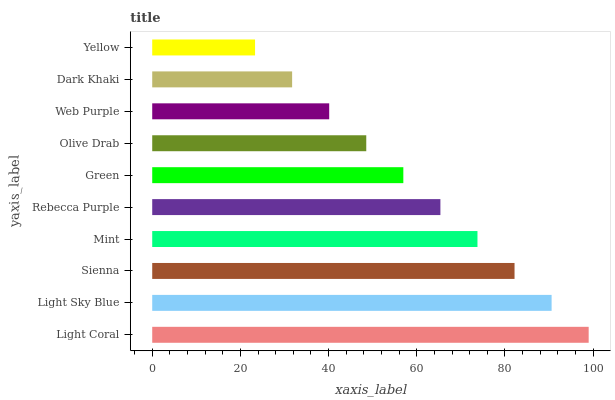Is Yellow the minimum?
Answer yes or no. Yes. Is Light Coral the maximum?
Answer yes or no. Yes. Is Light Sky Blue the minimum?
Answer yes or no. No. Is Light Sky Blue the maximum?
Answer yes or no. No. Is Light Coral greater than Light Sky Blue?
Answer yes or no. Yes. Is Light Sky Blue less than Light Coral?
Answer yes or no. Yes. Is Light Sky Blue greater than Light Coral?
Answer yes or no. No. Is Light Coral less than Light Sky Blue?
Answer yes or no. No. Is Rebecca Purple the high median?
Answer yes or no. Yes. Is Green the low median?
Answer yes or no. Yes. Is Mint the high median?
Answer yes or no. No. Is Sienna the low median?
Answer yes or no. No. 